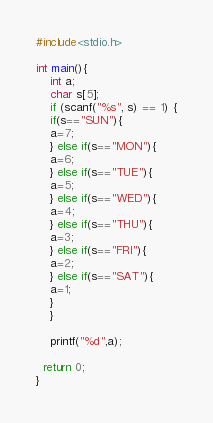<code> <loc_0><loc_0><loc_500><loc_500><_C_>#include<stdio.h>
 
int main(){
	int a;
  	char s[5];
  	if (scanf("%s", s) == 1) {
    if(s=="SUN"){
    a=7;
    } else if(s=="MON"){
    a=6;  
    } else if(s=="TUE"){
    a=5;
    } else if(s=="WED"){
    a=4;
    } else if(s=="THU"){
    a=3;
    } else if(s=="FRI"){
    a=2;
    } else if(s=="SAT"){
    a=1;
    } 
    }
      
  	printf("%d",a);
  
  return 0;
}</code> 